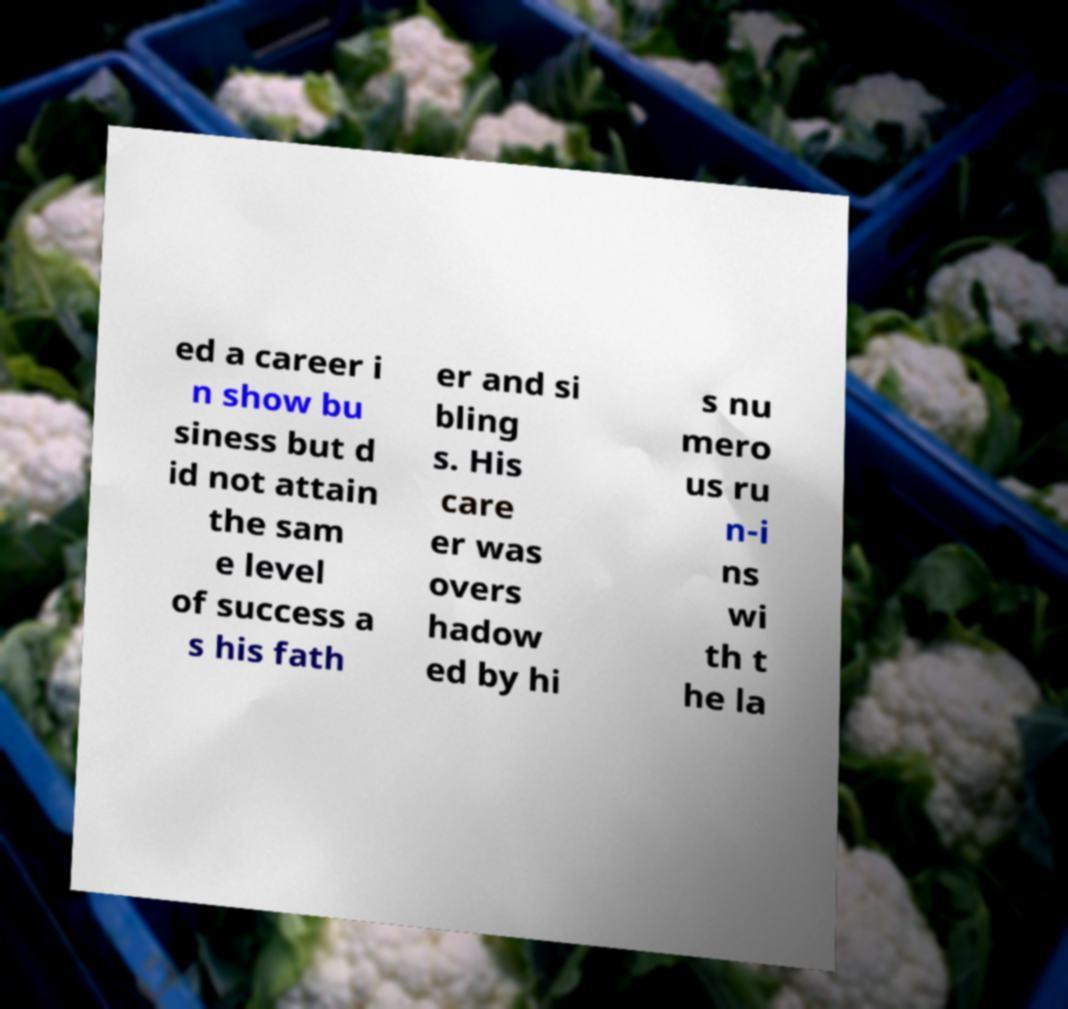There's text embedded in this image that I need extracted. Can you transcribe it verbatim? ed a career i n show bu siness but d id not attain the sam e level of success a s his fath er and si bling s. His care er was overs hadow ed by hi s nu mero us ru n-i ns wi th t he la 